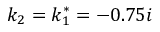<formula> <loc_0><loc_0><loc_500><loc_500>k _ { 2 } = k _ { 1 } ^ { * } = - 0 . 7 5 i</formula> 